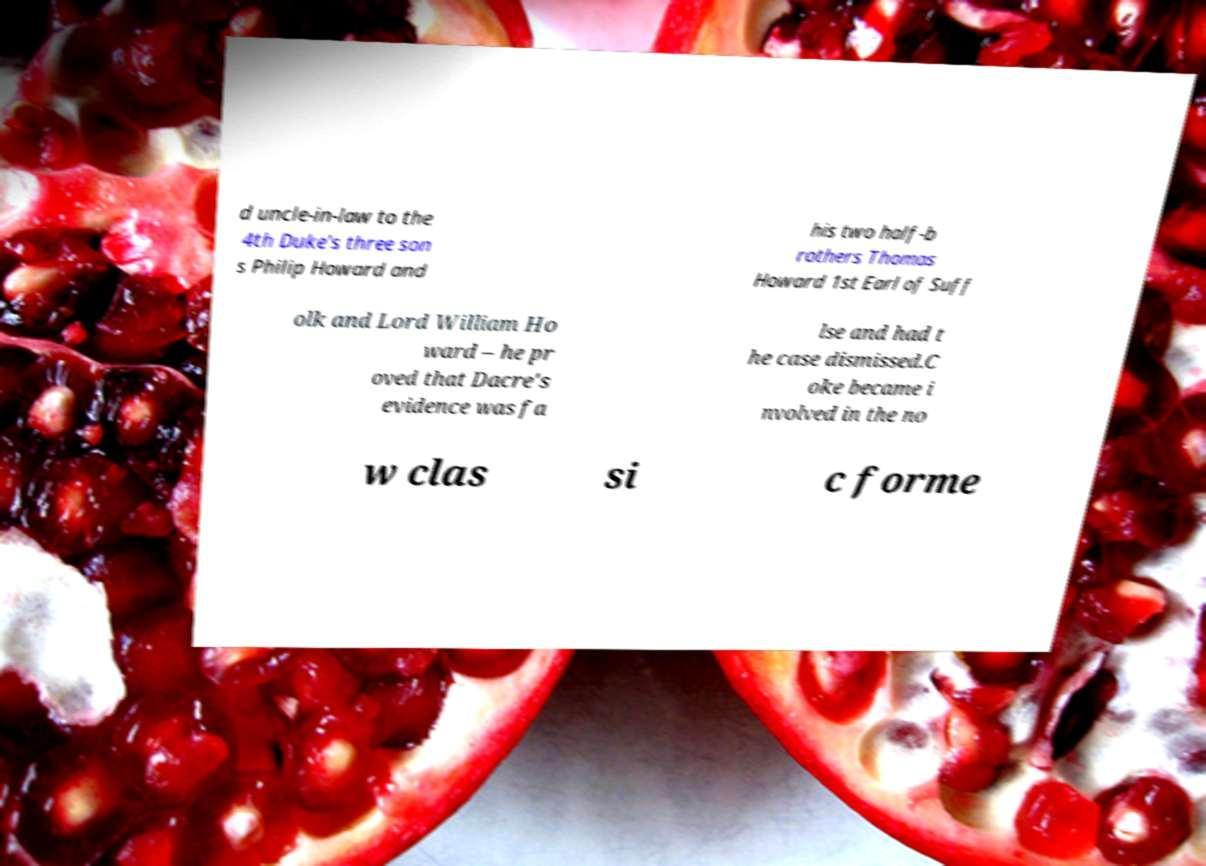What messages or text are displayed in this image? I need them in a readable, typed format. d uncle-in-law to the 4th Duke's three son s Philip Howard and his two half-b rothers Thomas Howard 1st Earl of Suff olk and Lord William Ho ward – he pr oved that Dacre's evidence was fa lse and had t he case dismissed.C oke became i nvolved in the no w clas si c forme 